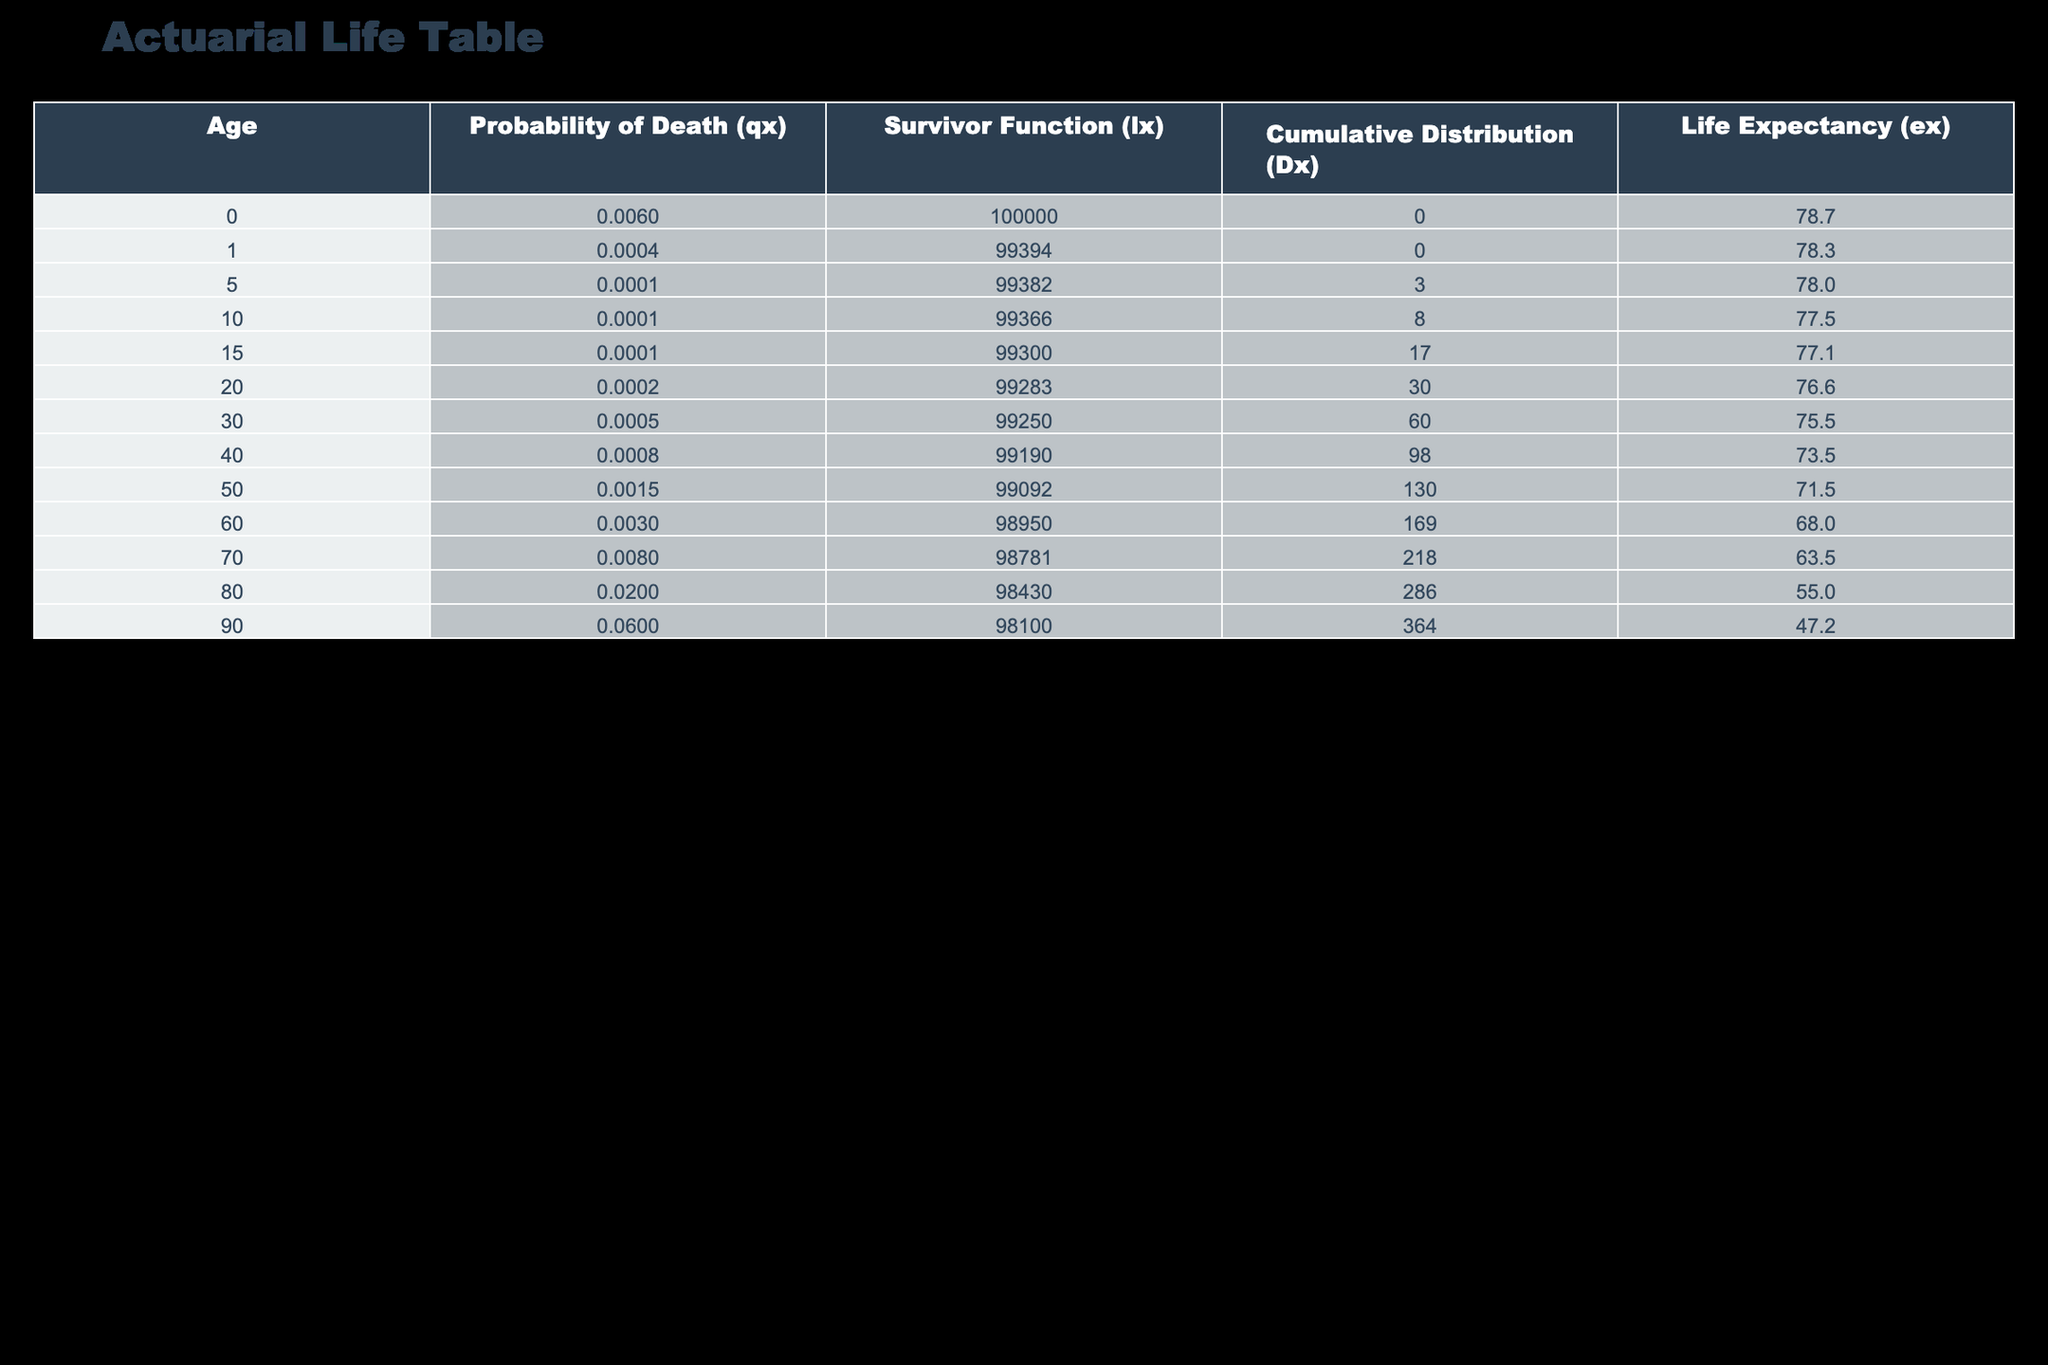What is the life expectancy at age 0? From the table, the life expectancy (ex) for age 0 is directly provided as 78.7 years.
Answer: 78.7 What is the probability of death at age 80? The probability of death (qx) at age 80 is directly found in the table, which is 0.02.
Answer: 0.02 How many individuals survive to age 60? The survivor function (lx) at age 60 indicates that 98,950 individuals are expected to survive to that age.
Answer: 98950 What is the difference in life expectancy between ages 50 and 70? The life expectancy at age 50 is 71.5 years and at age 70 is 63.5 years. The difference is 71.5 - 63.5 = 8 years.
Answer: 8 Is the probability of death at age 90 greater than that at age 40? The probability of death at age 90 is 0.06 while at age 40 it is 0.0008. Since 0.06 > 0.0008, the answer is yes.
Answer: Yes What is the average life expectancy for ages 30 to 60? The life expectancies are 75.5 (age 30), 73.5 (age 40), 71.5 (age 50), and 68.0 (age 60). Summing these gives 75.5 + 73.5 + 71.5 + 68.0 = 288. The average is 288 / 4 = 72.0 years.
Answer: 72.0 How many deaths are expected cumulatively by age 80? The cumulative distribution (Dx) at age 80 is given as 286. This indicates a total of 286 deaths expected by that age.
Answer: 286 Is the number of individuals surviving until age 15 greater than 99,000? The survivor function (lx) at age 15 shows 99,300 individuals surviving, which is greater than 99,000. Therefore, the answer is yes.
Answer: Yes What is the cumulative number of deaths by age 90? For age 90, the cumulative deaths (Dx) is 364 as shown in the table.
Answer: 364 